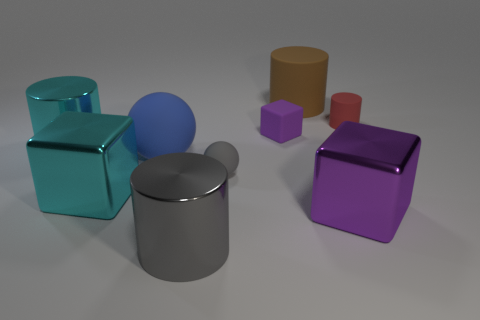What number of other things are made of the same material as the blue sphere?
Your answer should be compact. 4. There is a ball behind the small gray rubber object; how big is it?
Your response must be concise. Large. How many things are both behind the blue thing and on the left side of the blue ball?
Keep it short and to the point. 1. There is a large cylinder that is in front of the purple block in front of the small purple cube; what is its material?
Ensure brevity in your answer.  Metal. What material is the tiny object that is the same shape as the large gray thing?
Provide a short and direct response. Rubber. Are any blue things visible?
Your response must be concise. Yes. What shape is the tiny purple thing that is made of the same material as the tiny cylinder?
Give a very brief answer. Cube. There is a large object that is in front of the large purple shiny block; what material is it?
Your answer should be very brief. Metal. There is a metallic block that is left of the big gray cylinder; is its color the same as the large sphere?
Make the answer very short. No. There is a cylinder that is to the right of the object that is behind the tiny red matte object; how big is it?
Offer a terse response. Small. 